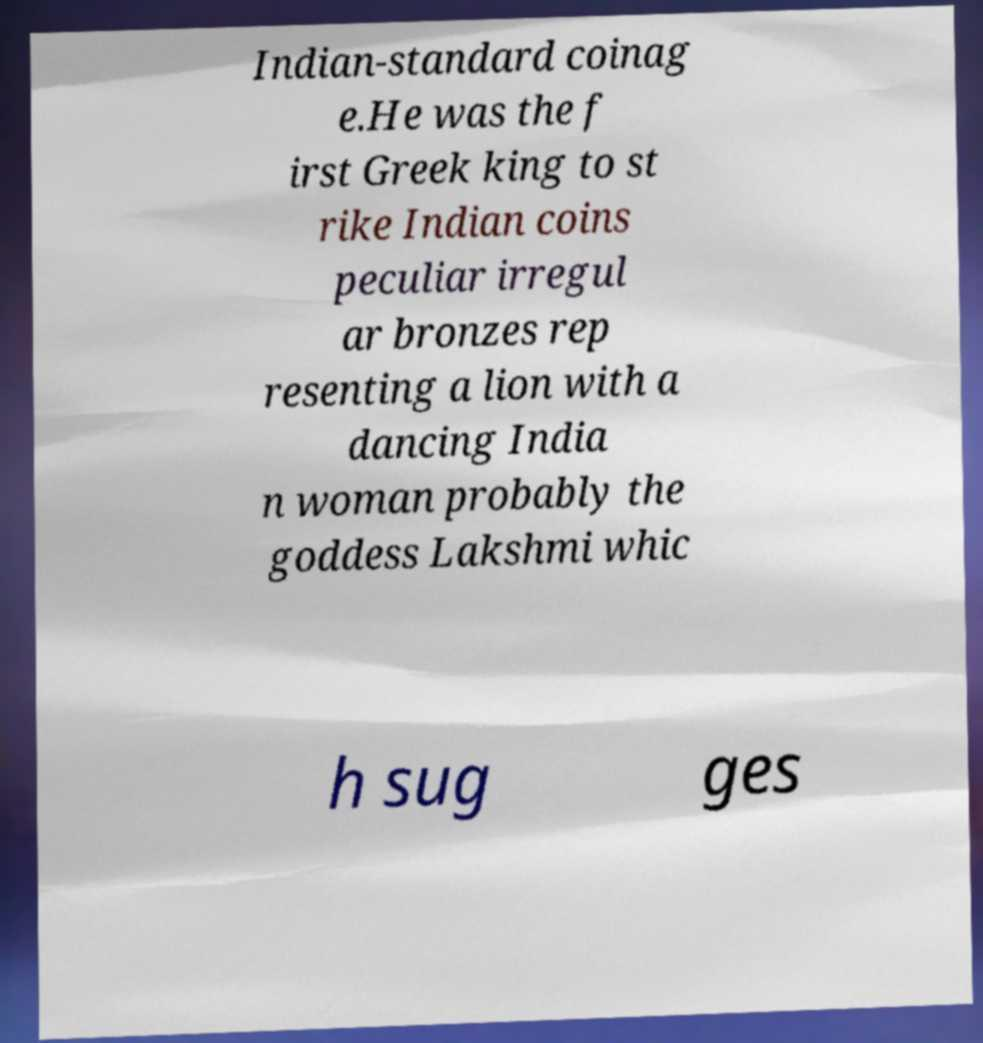For documentation purposes, I need the text within this image transcribed. Could you provide that? Indian-standard coinag e.He was the f irst Greek king to st rike Indian coins peculiar irregul ar bronzes rep resenting a lion with a dancing India n woman probably the goddess Lakshmi whic h sug ges 